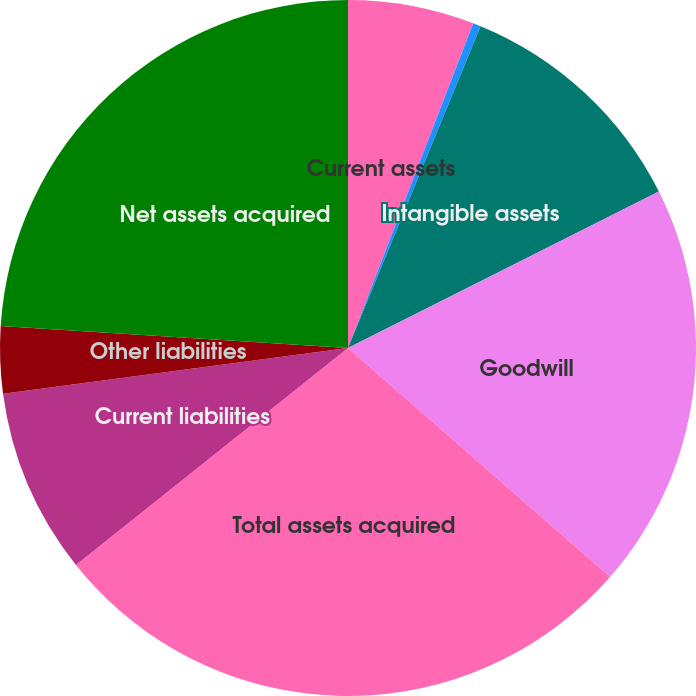Convert chart. <chart><loc_0><loc_0><loc_500><loc_500><pie_chart><fcel>Current assets<fcel>Other assets<fcel>Intangible assets<fcel>Goodwill<fcel>Total assets acquired<fcel>Current liabilities<fcel>Other liabilities<fcel>Net assets acquired<nl><fcel>5.86%<fcel>0.36%<fcel>11.36%<fcel>18.85%<fcel>27.85%<fcel>8.61%<fcel>3.11%<fcel>23.99%<nl></chart> 